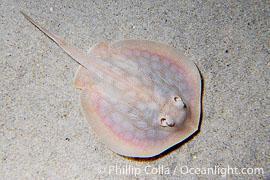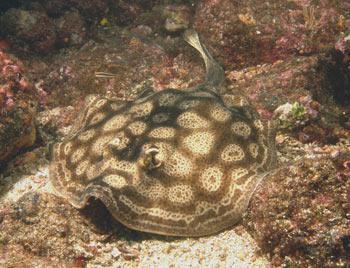The first image is the image on the left, the second image is the image on the right. For the images displayed, is the sentence "In the left image, there's a single round stingray facing the lower right." factually correct? Answer yes or no. Yes. The first image is the image on the left, the second image is the image on the right. Considering the images on both sides, is "In at least one image a stingray's spine points to the 10:00 position." valid? Answer yes or no. Yes. 